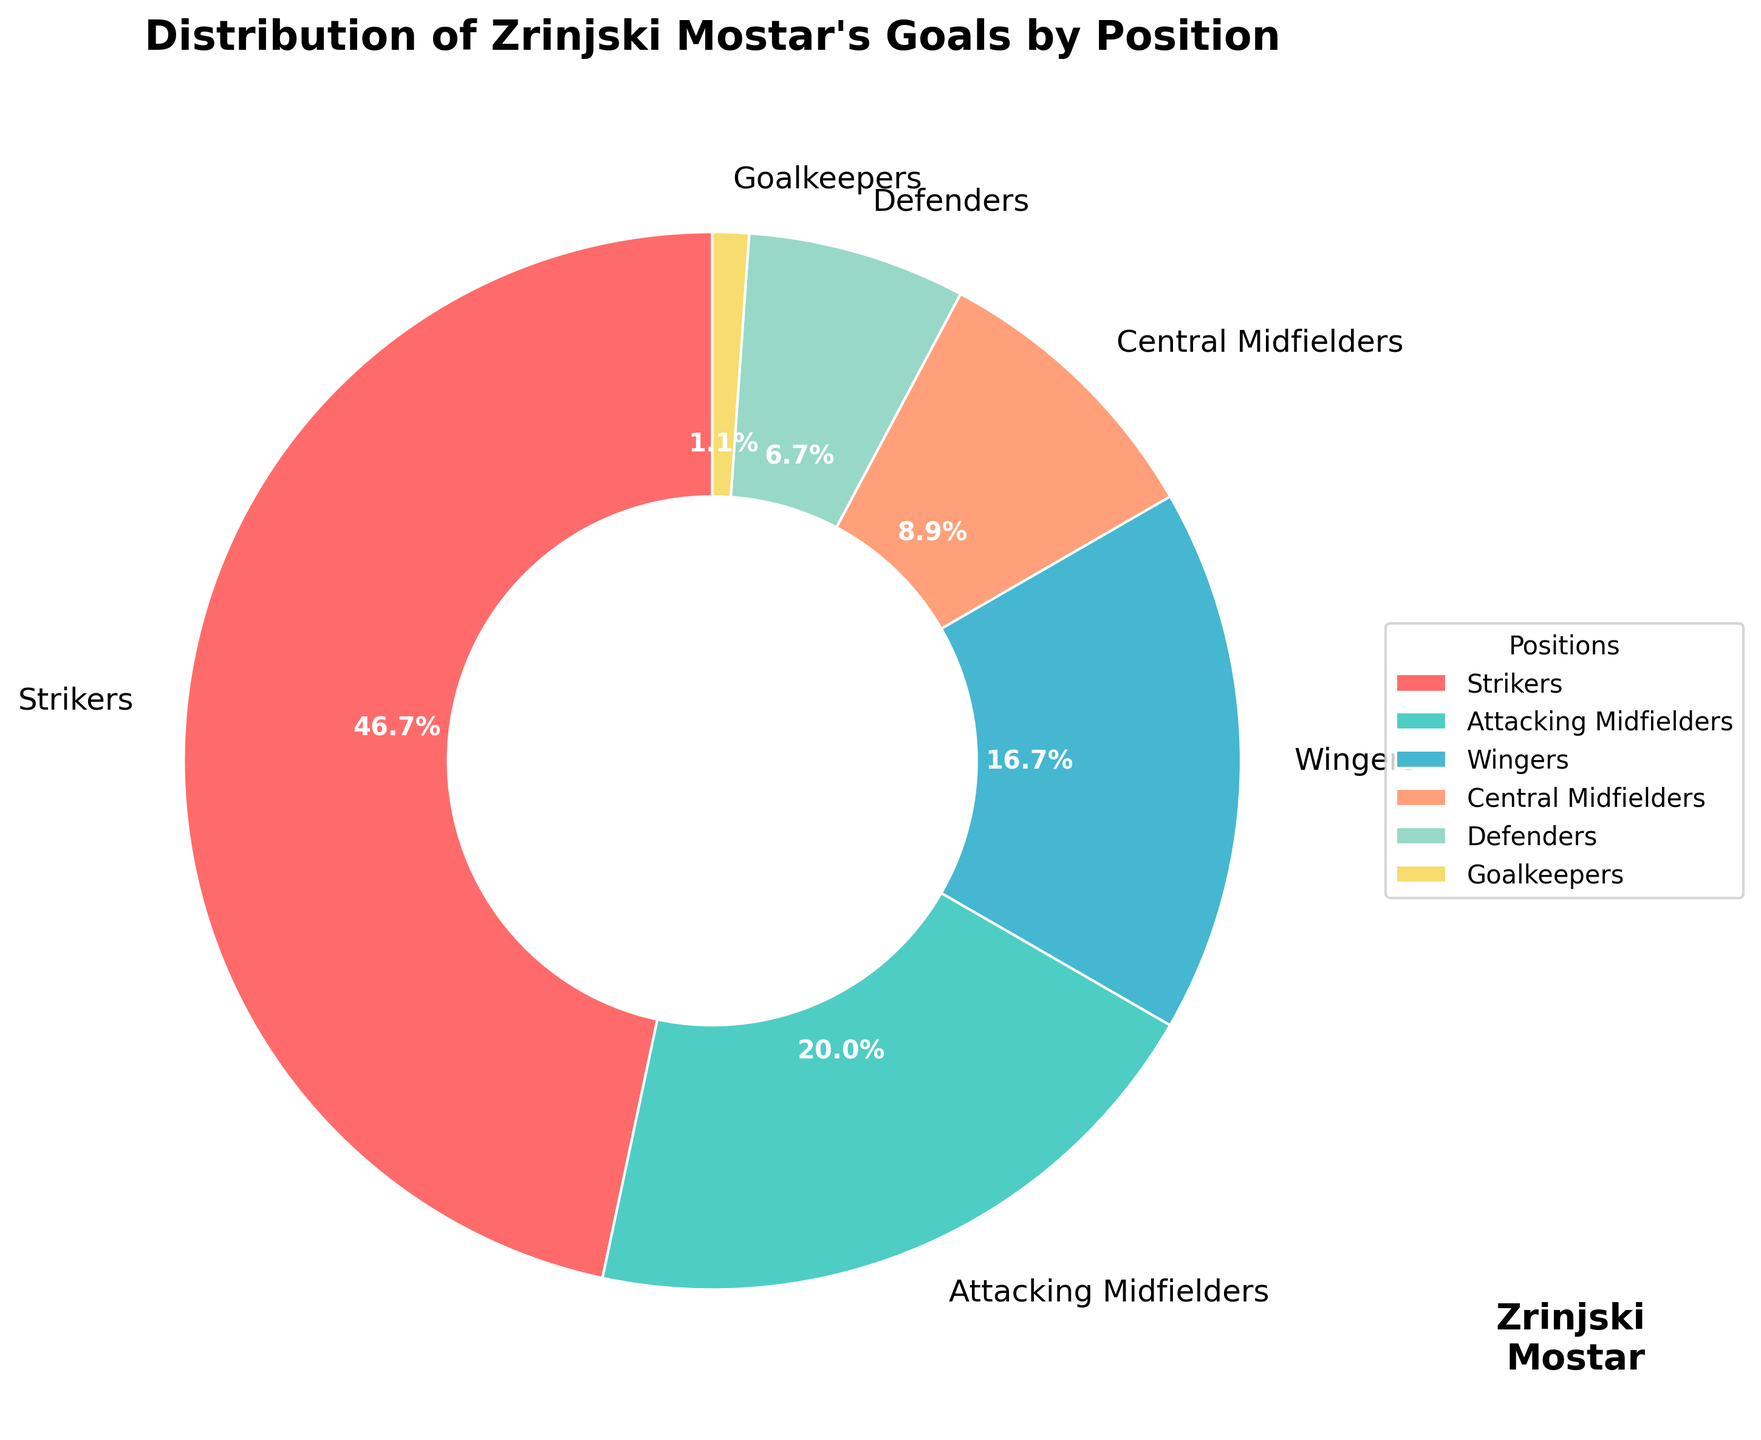Which position scored the most goals? The figure shows the distribution of goals scored by each position, and the largest slice corresponds to the strikers, indicating they scored the most goals.
Answer: Strikers What percentage of the total goals were scored by the wingers? The figure uses percentages to label each slice. The label for wingers shows that they scored 15% of the total goals.
Answer: 15% How many more goals did the strikers score compared to the defenders? From the figure, strikers scored 42 goals, and defenders scored 6 goals. The difference is 42 - 6 = 36 goals.
Answer: 36 Are there more goals scored by attacking midfielders or central midfielders? Visually comparing the sizes of the slices for attacking midfielders and central midfielders shows that the attacking midfielders' slice is larger.
Answer: Attacking Midfielders What combined percentage of goals did the central midfielders and defenders contribute? Central midfielders contributed 8% and defenders contributed 6%. Combined, they contributed 8% + 6% = 14%.
Answer: 14% Identify the position with the least goals scored and state the number of goals. The smallest slice represents the goalkeepers, indicating they scored the least goals, which is 1.
Answer: Goalkeepers, 1 How many goals were scored by positions other than strikers? To find this, sum the goals scored by all other positions: 18 (attacking midfielders) + 15 (wingers) + 8 (central midfielders) + 6 (defenders) + 1 (goalkeepers) = 48 goals.
Answer: 48 What is the ratio of goals scored by strikers to the total number of goals scored? The total number of goals is 42 (strikers) + 18 (attacking midfielders) + 15 (wingers) + 8 (central midfielders) + 6 (defenders) + 1 (goalkeepers) = 90. The ratio is 42/90.
Answer: 42/90 Who scored a higher percentage of goals: central midfielders or defenders? The figure shows that central midfielders scored 8% of goals and defenders scored 6%. Central midfielders scored a higher percentage.
Answer: Central Midfielders 